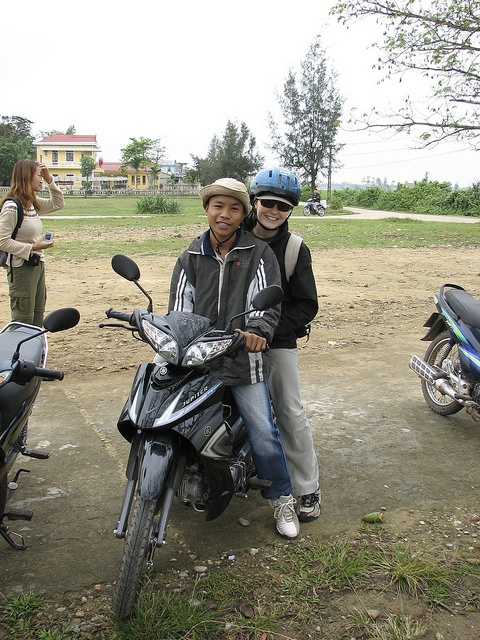Describe the objects in this image and their specific colors. I can see motorcycle in white, black, gray, darkgray, and tan tones, people in white, black, gray, darkgray, and lightgray tones, people in white, black, darkgray, and gray tones, motorcycle in white, black, gray, and darkgray tones, and people in white, gray, black, and darkgray tones in this image. 